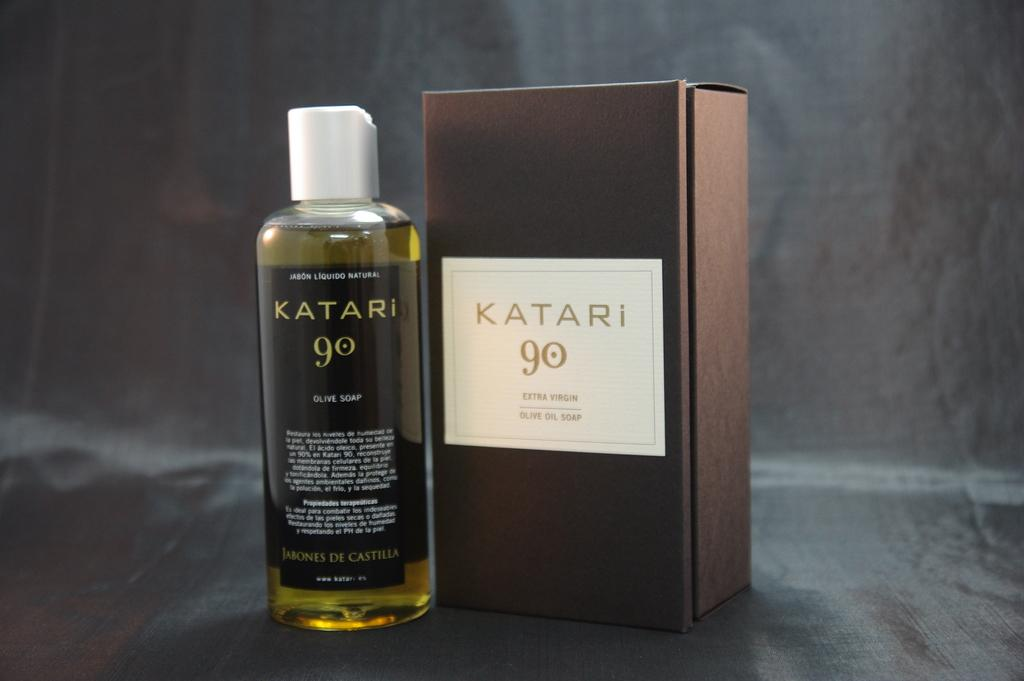<image>
Relay a brief, clear account of the picture shown. A bottle of Katari 90 olive soap and it's box. 